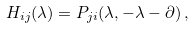<formula> <loc_0><loc_0><loc_500><loc_500>H _ { i j } ( \lambda ) = P _ { j i } ( \lambda , - \lambda - \partial ) \, ,</formula> 